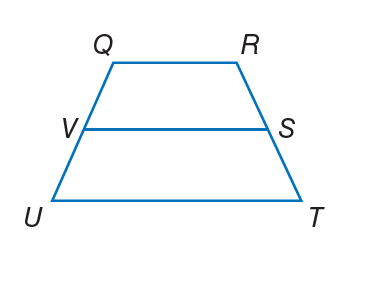Answer the mathemtical geometry problem and directly provide the correct option letter.
Question: For trapezoid Q R T U, V and S are midpoints of the legs. If T U = 26 and S V = 17, find Q R.
Choices: A: 8 B: 12 C: 20 D: 34 A 